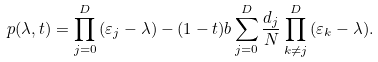<formula> <loc_0><loc_0><loc_500><loc_500>p ( \lambda , t ) = \prod _ { j = 0 } ^ { D } { ( \varepsilon _ { j } - \lambda ) } - ( 1 - t ) b \sum _ { j = 0 } ^ { D } { \frac { d _ { j } } { N } \prod _ { k \neq j } ^ { D } { ( \varepsilon _ { k } - \lambda ) } } .</formula> 